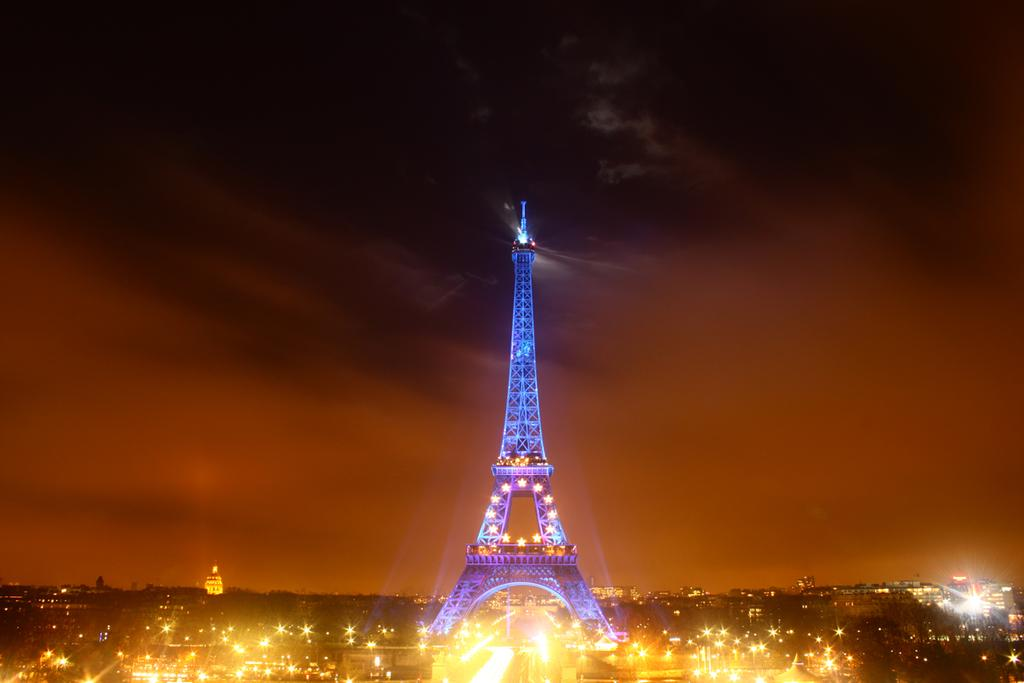What famous landmark can be seen in the image? The Eiffel Tower is visible in the image. What else is present in the image besides the Eiffel Tower? There are buildings and lights in the image. What part of the natural environment is visible in the image? The sky is visible in the image. Where is the wren perched in the image? There is no wren present in the image. What type of stage can be seen in the image? There is no stage present in the image. 